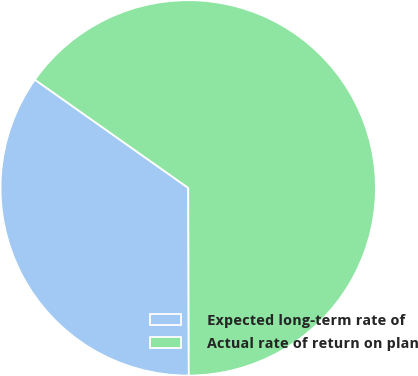<chart> <loc_0><loc_0><loc_500><loc_500><pie_chart><fcel>Expected long-term rate of<fcel>Actual rate of return on plan<nl><fcel>34.83%<fcel>65.17%<nl></chart> 